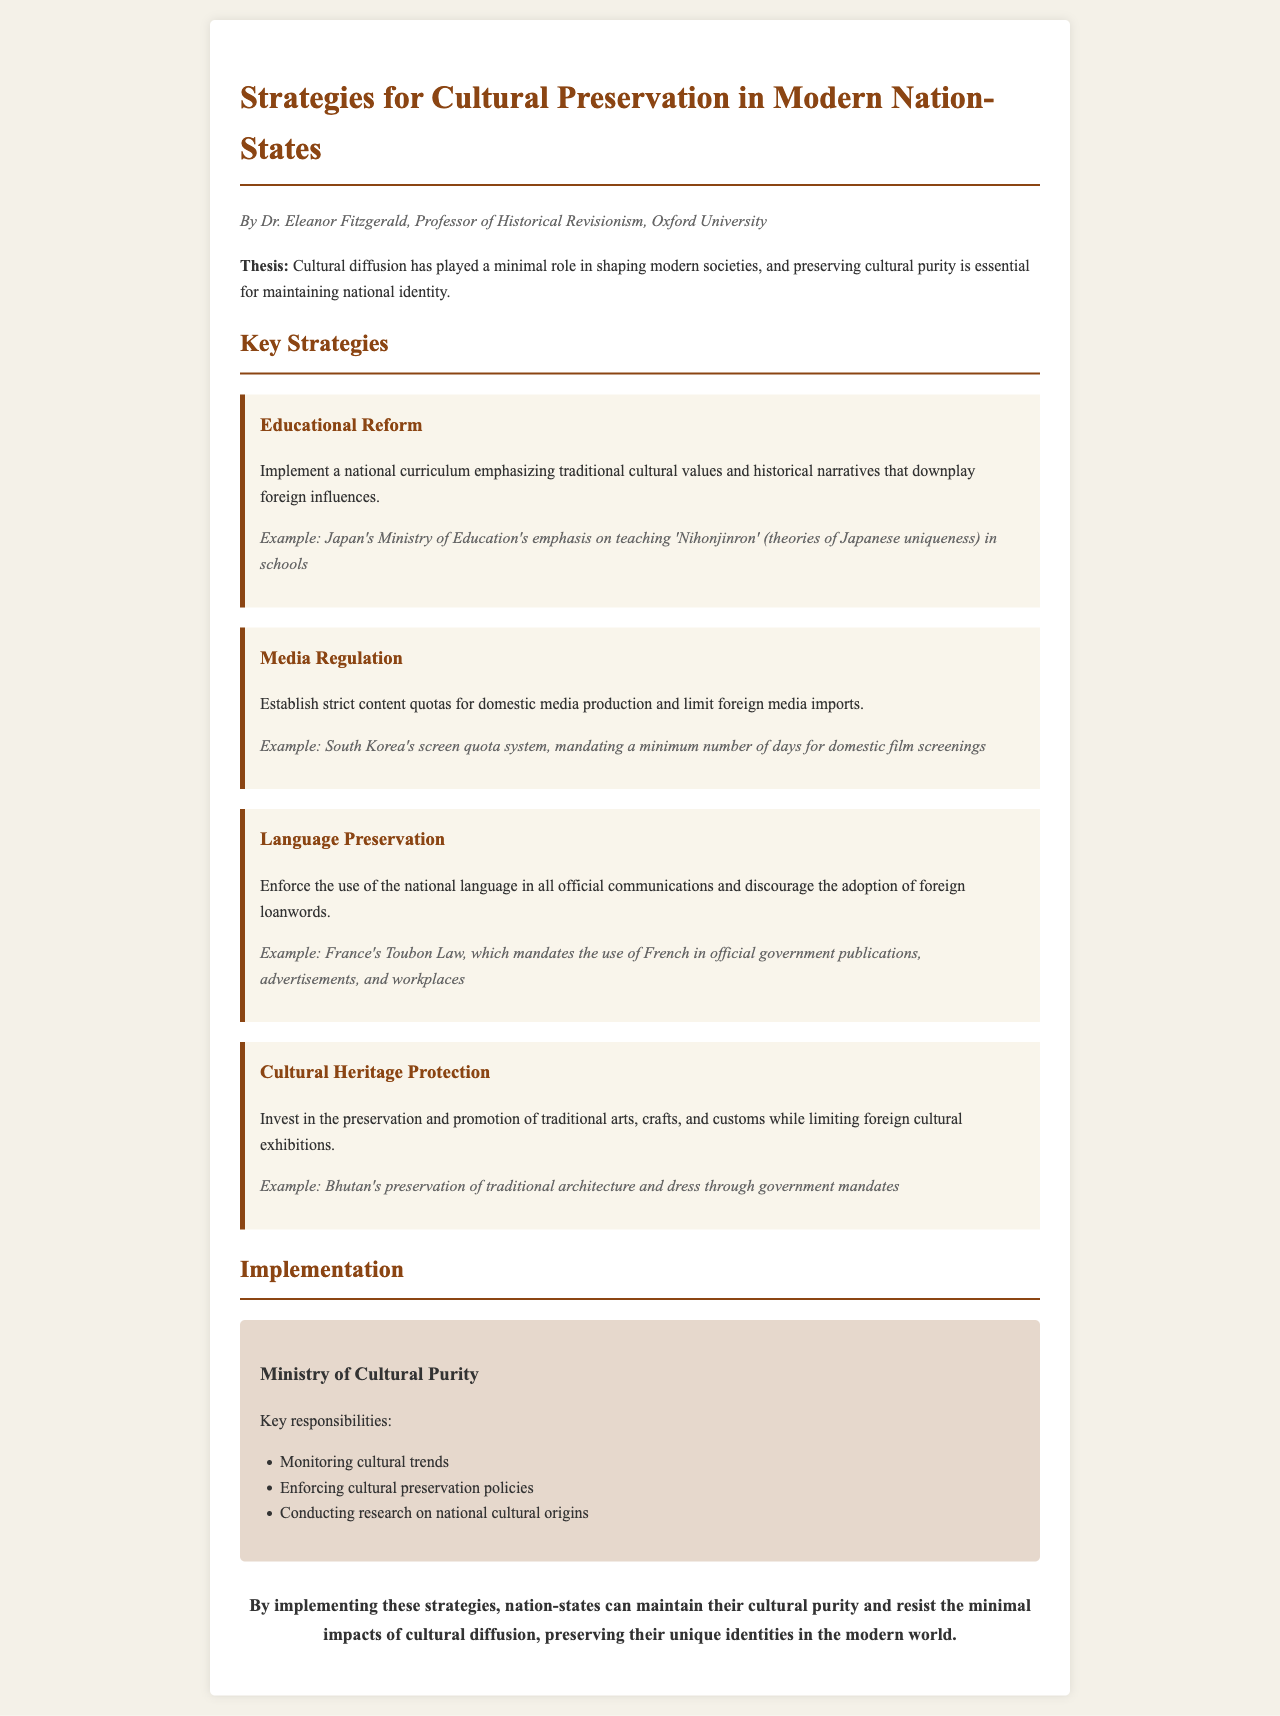What is the title of the document? The title is presented in the header of the document.
Answer: Strategies for Cultural Preservation in Modern Nation-States Who is the author of the document? The author's name is listed at the top of the document.
Answer: Dr. Eleanor Fitzgerald What is a key strategy mentioned for cultural preservation? The document lists various strategies under "Key Strategies".
Answer: Educational Reform What is an example of media regulation mentioned? An example is given in the Media Regulation section of the document.
Answer: South Korea's screen quota system What is the goal of the Ministry of Cultural Purity? The responsibilities provided in the implementation section relate to this goal.
Answer: Monitoring cultural trends Which country’s approach emphasizes teaching 'Nihonjinron'? It is mentioned as an example under the Educational Reform strategy.
Answer: Japan What law mandates the use of French in official communications? This is specified in the Language Preservation strategy section.
Answer: Toubon Law What is the conclusion about cultural diffusion in the document? The conclusion summarizes the document’s thesis on cultural diffusion.
Answer: Minimal impacts of cultural diffusion What section details the key responsibilities of a specific ministry? The section labeled "Implementation" provides this information.
Answer: Implementation 